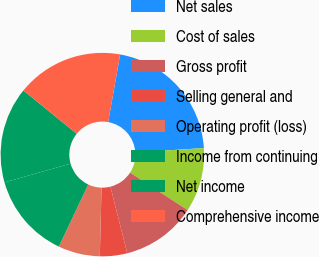Convert chart. <chart><loc_0><loc_0><loc_500><loc_500><pie_chart><fcel>Net sales<fcel>Cost of sales<fcel>Gross profit<fcel>Selling general and<fcel>Operating profit (loss)<fcel>Income from continuing<fcel>Net income<fcel>Comprehensive income<nl><fcel>21.17%<fcel>10.21%<fcel>11.89%<fcel>4.33%<fcel>6.63%<fcel>13.57%<fcel>15.26%<fcel>16.94%<nl></chart> 